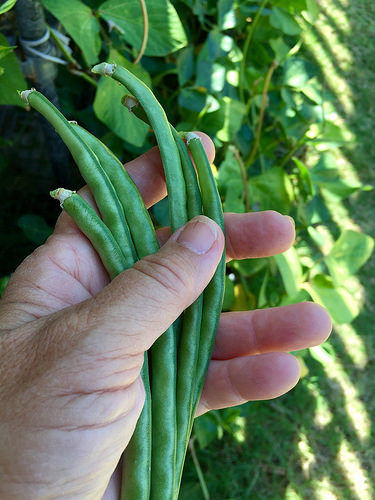<image>
Can you confirm if the beans is next to the hands? No. The beans is not positioned next to the hands. They are located in different areas of the scene. Is the thumb in front of the bean? Yes. The thumb is positioned in front of the bean, appearing closer to the camera viewpoint. 